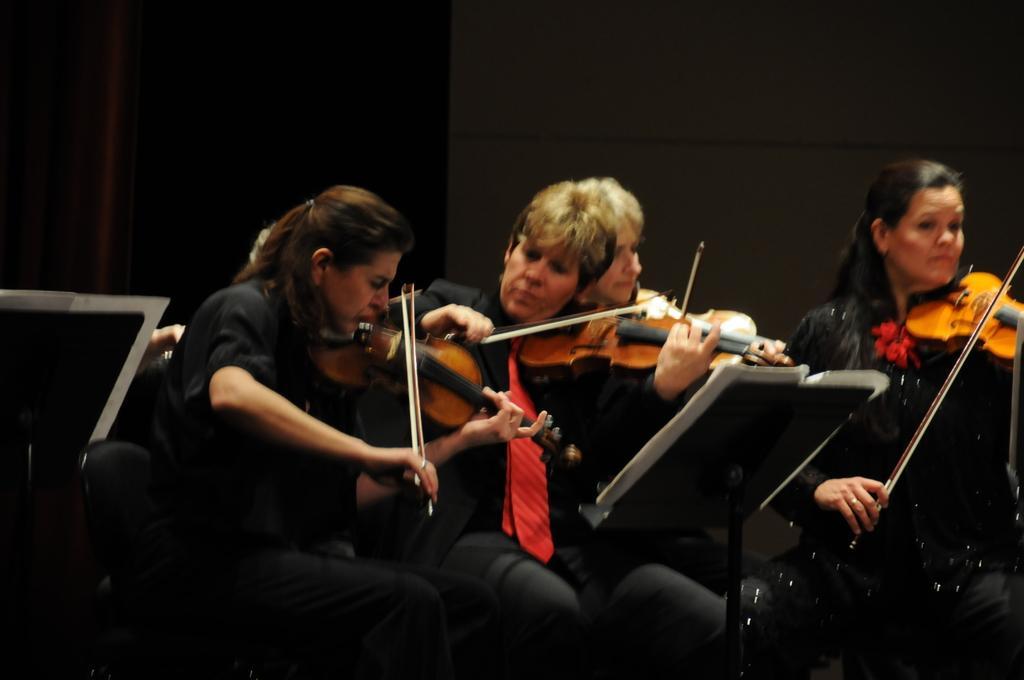Please provide a concise description of this image. In this picture we can see a few people playing musical instruments. There are some papers and some black objects. We can see a wall in the background. 